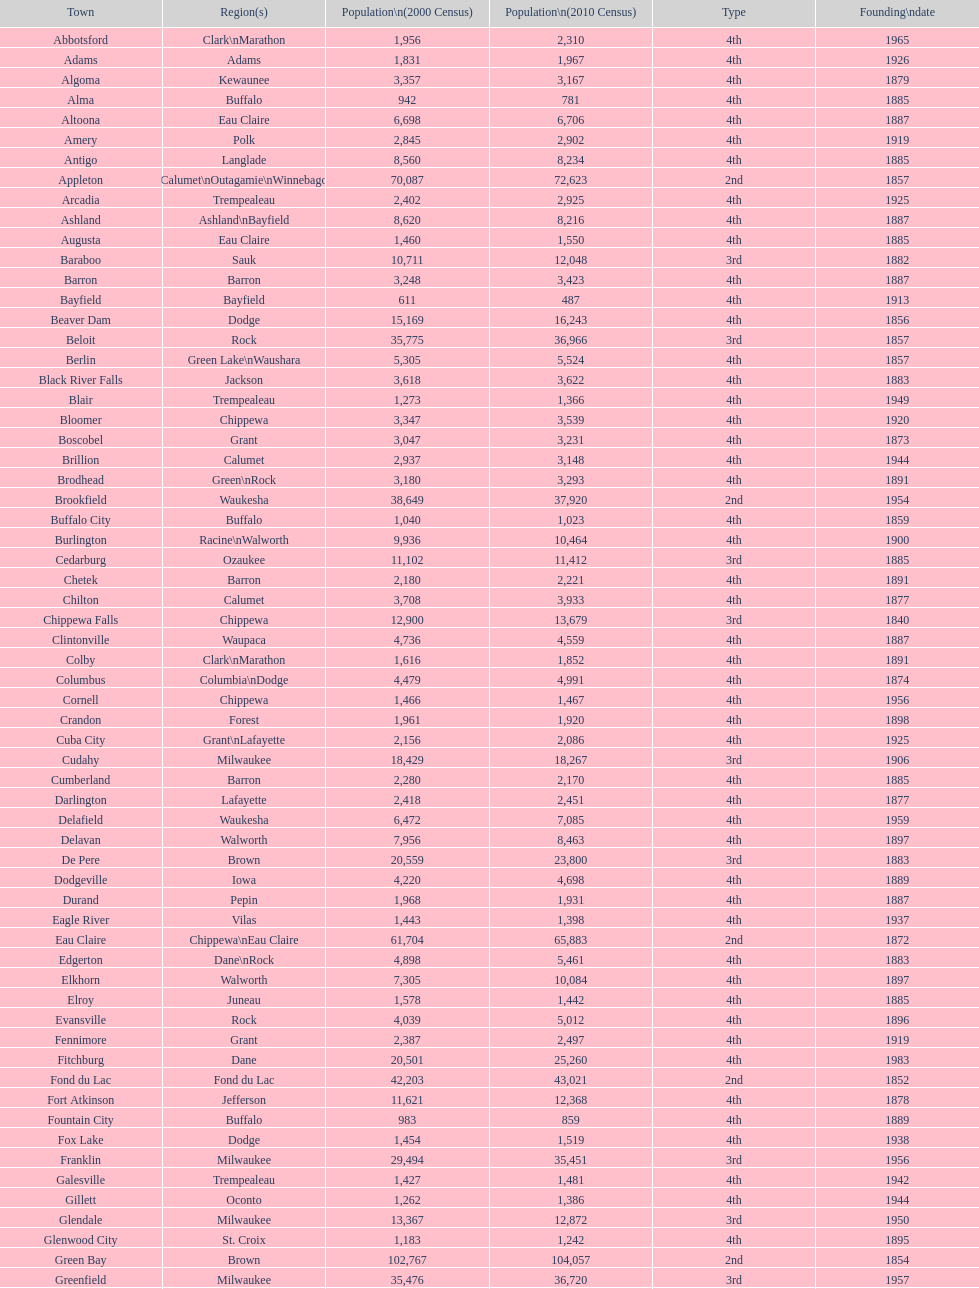How many cities have 1926 as their incorporation date? 2. 